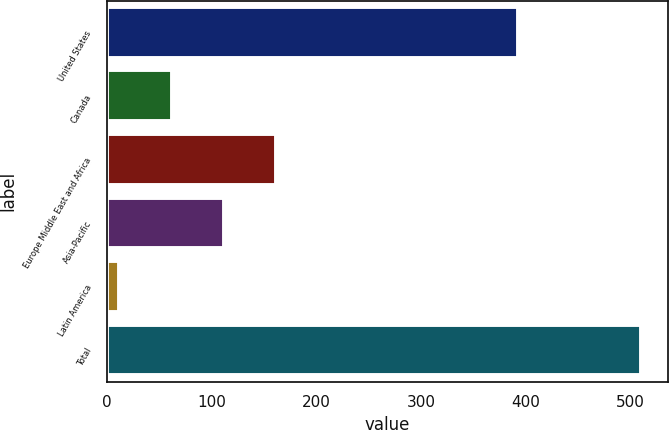Convert chart to OTSL. <chart><loc_0><loc_0><loc_500><loc_500><bar_chart><fcel>United States<fcel>Canada<fcel>Europe Middle East and Africa<fcel>Asia-Pacific<fcel>Latin America<fcel>Total<nl><fcel>392.3<fcel>61.92<fcel>161.56<fcel>111.74<fcel>12.1<fcel>510.3<nl></chart> 